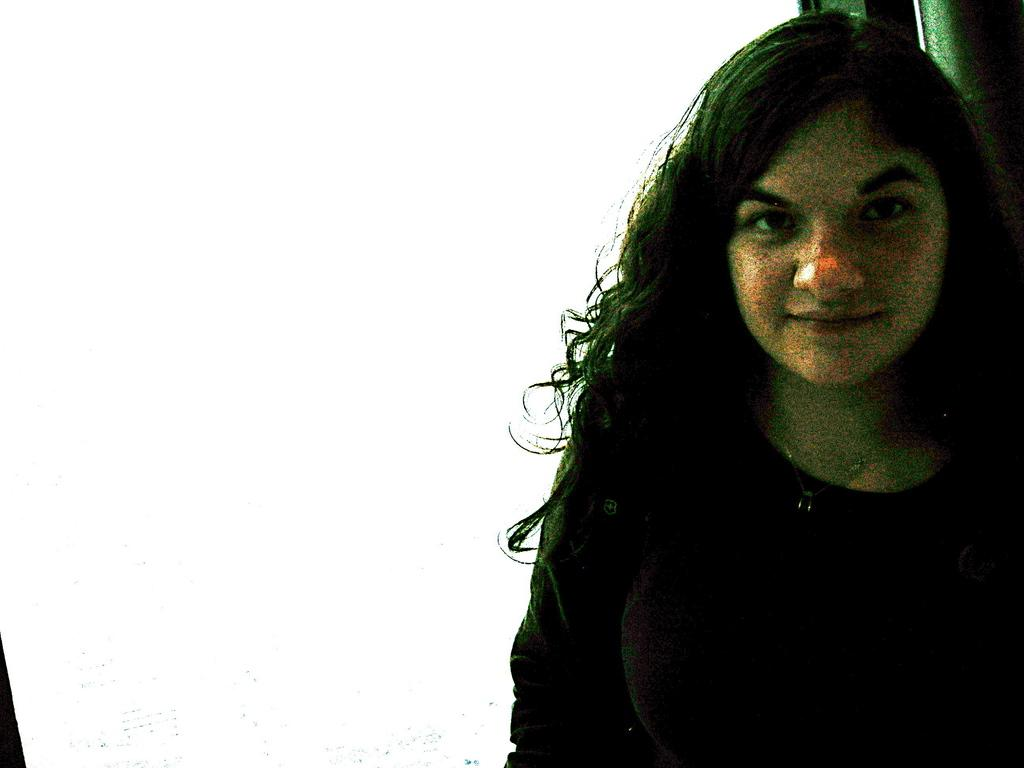What is the main subject of the image? The main subject of the image is a woman. Are there any bears wearing hats in the image? No, there are no bears or hats present in the image. 